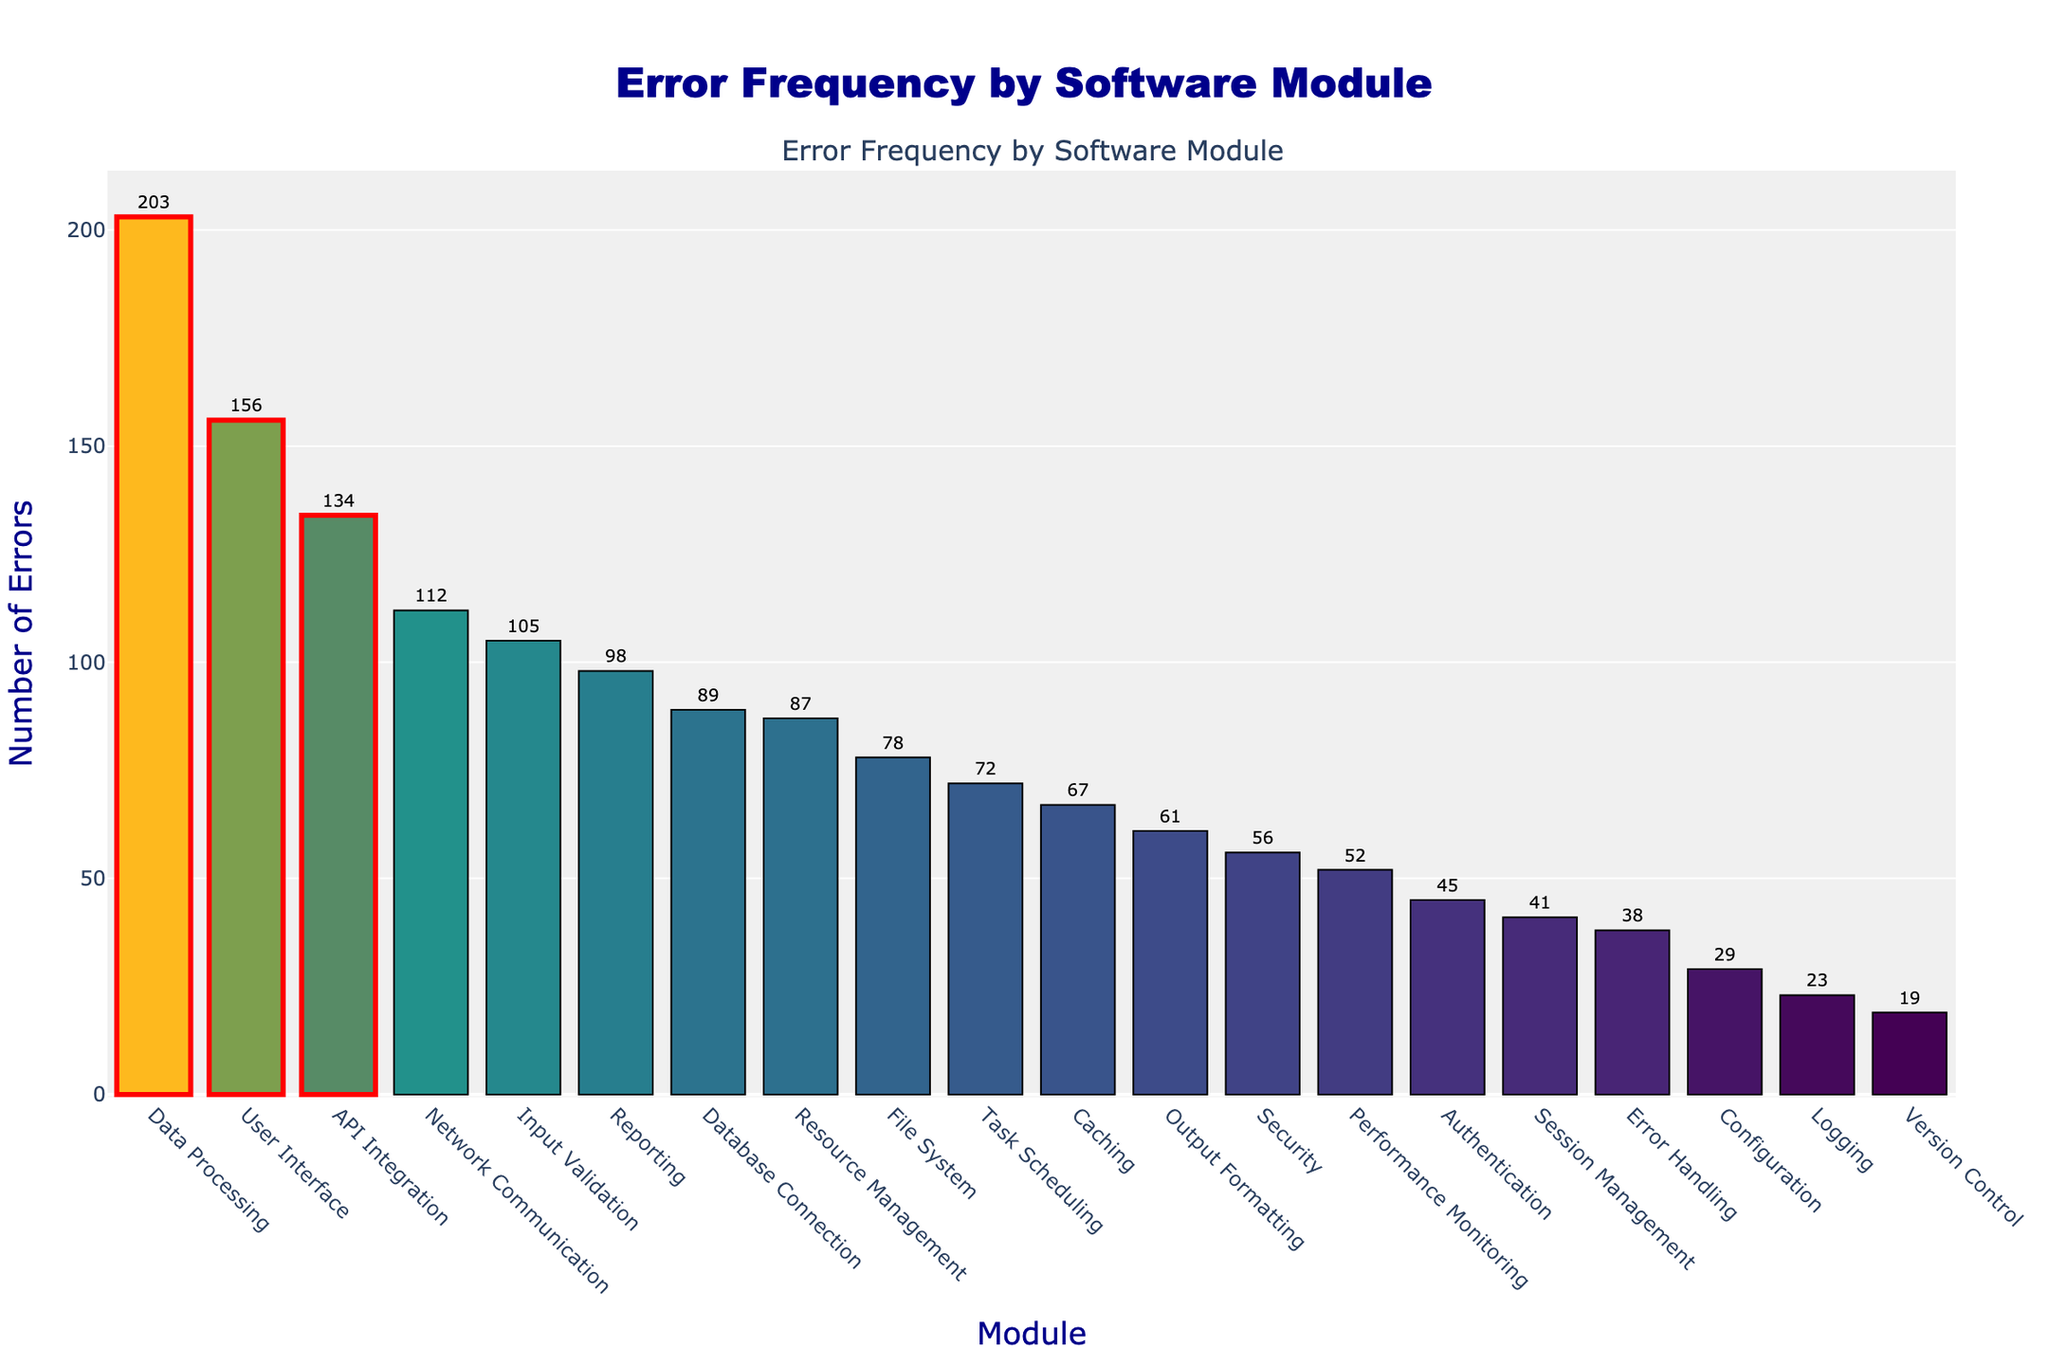What are the top three modules with the highest number of errors? Look at the bars that are marked and highlighted with a red rectangle on the figure. These indicate the modules with the highest error counts.
Answer: Data Processing, User Interface, API Integration How many more errors does the User Interface module have compared to the Security module? Identify the error counts for both modules from the figure. The User Interface has 156 errors, and the Security module has 56 errors. Calculate the difference: 156 - 56 = 100
Answer: 100 Which module has the second-lowest number of errors? Sort the bars in ascending order of error count and note the second bar from the left. The Version Control module has the fewest errors (19), and Configuration has the second fewest (29).
Answer: Configuration What is the total number of errors for the modules Data Processing and Network Communication? Add the error counts for Data Processing and Network Communication from the figure. Data Processing has 203 errors, and Network Communication has 112 errors. The total is 203 + 112 = 315
Answer: 315 What is the average number of errors across all modules? Sum all error counts from each module, then divide by the number of modules. Summing all errors: 156 + 89 + 45 + 78 + 112 + 203 + 23 + 67 + 134 + 56 + 41 + 29 + 98 + 72 + 38 + 105 + 61 + 52 + 87 + 19 = 1565. Number of modules = 20. Average = 1565 / 20 = 78.25
Answer: 78.25 Which of the highlighted modules has the smallest number of errors? Look at the highlighted modules and compare their error counts. The highlighted modules are Data Processing (203), User Interface (156), and API Integration (134). API Integration has the smallest count among them.
Answer: API Integration By how much does the error count of the Data Processing module exceed the average number of errors? First, calculate the average number of errors across all modules, which is 78.25. The Data Processing module has 203 errors. The difference is 203 - 78.25 = 124.75
Answer: 124.75 Which module has more errors, File System or Database Connection, and what is the difference? Compare the error counts for both modules from the figure. The File System module has 78 errors, and the Database Connection module has 89 errors. The difference is 89 - 78 = 11.
Answer: Database Connection, 11 